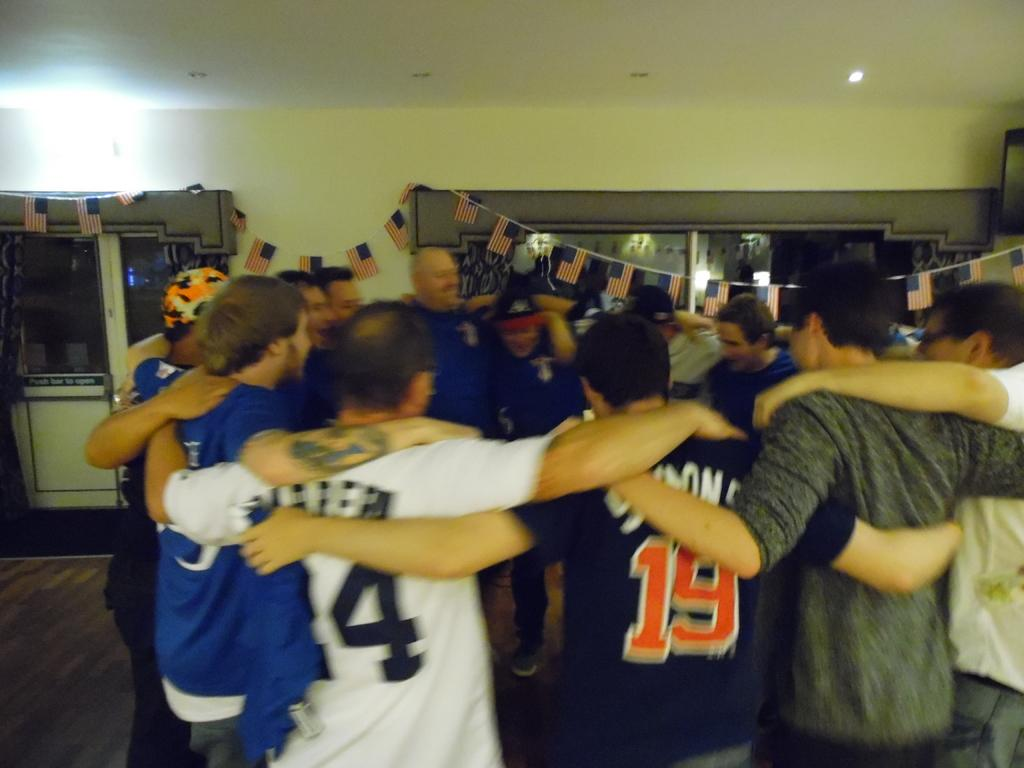<image>
Provide a brief description of the given image. Fans huddle up with arms around each other including one wearing the number 19. 